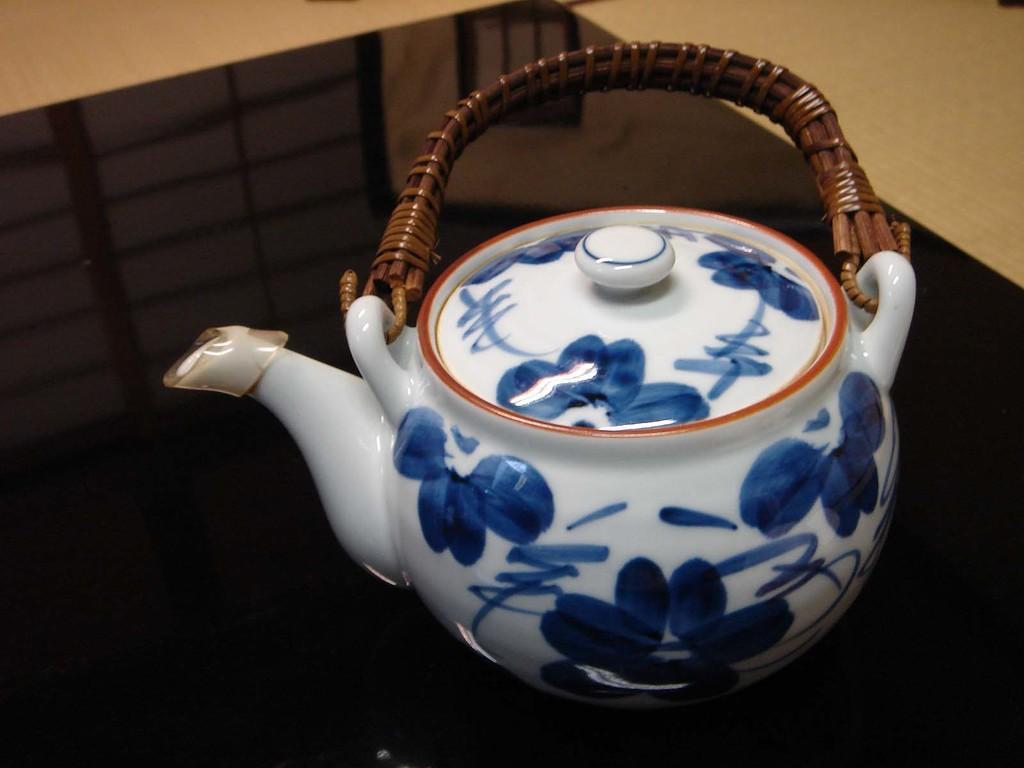Could you give a brief overview of what you see in this image? In this image on a table there is a kettle. This is the floor. 